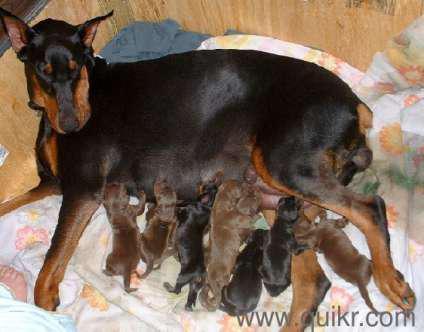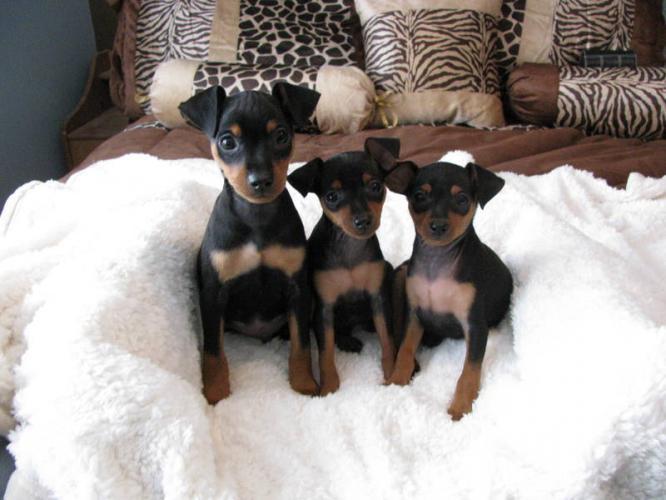The first image is the image on the left, the second image is the image on the right. Evaluate the accuracy of this statement regarding the images: "The right image features at least two puppies sitting upright with faces forward on a plush white blanket.". Is it true? Answer yes or no. Yes. The first image is the image on the left, the second image is the image on the right. Considering the images on both sides, is "At least one of the dogs is standing on all fours." valid? Answer yes or no. No. 